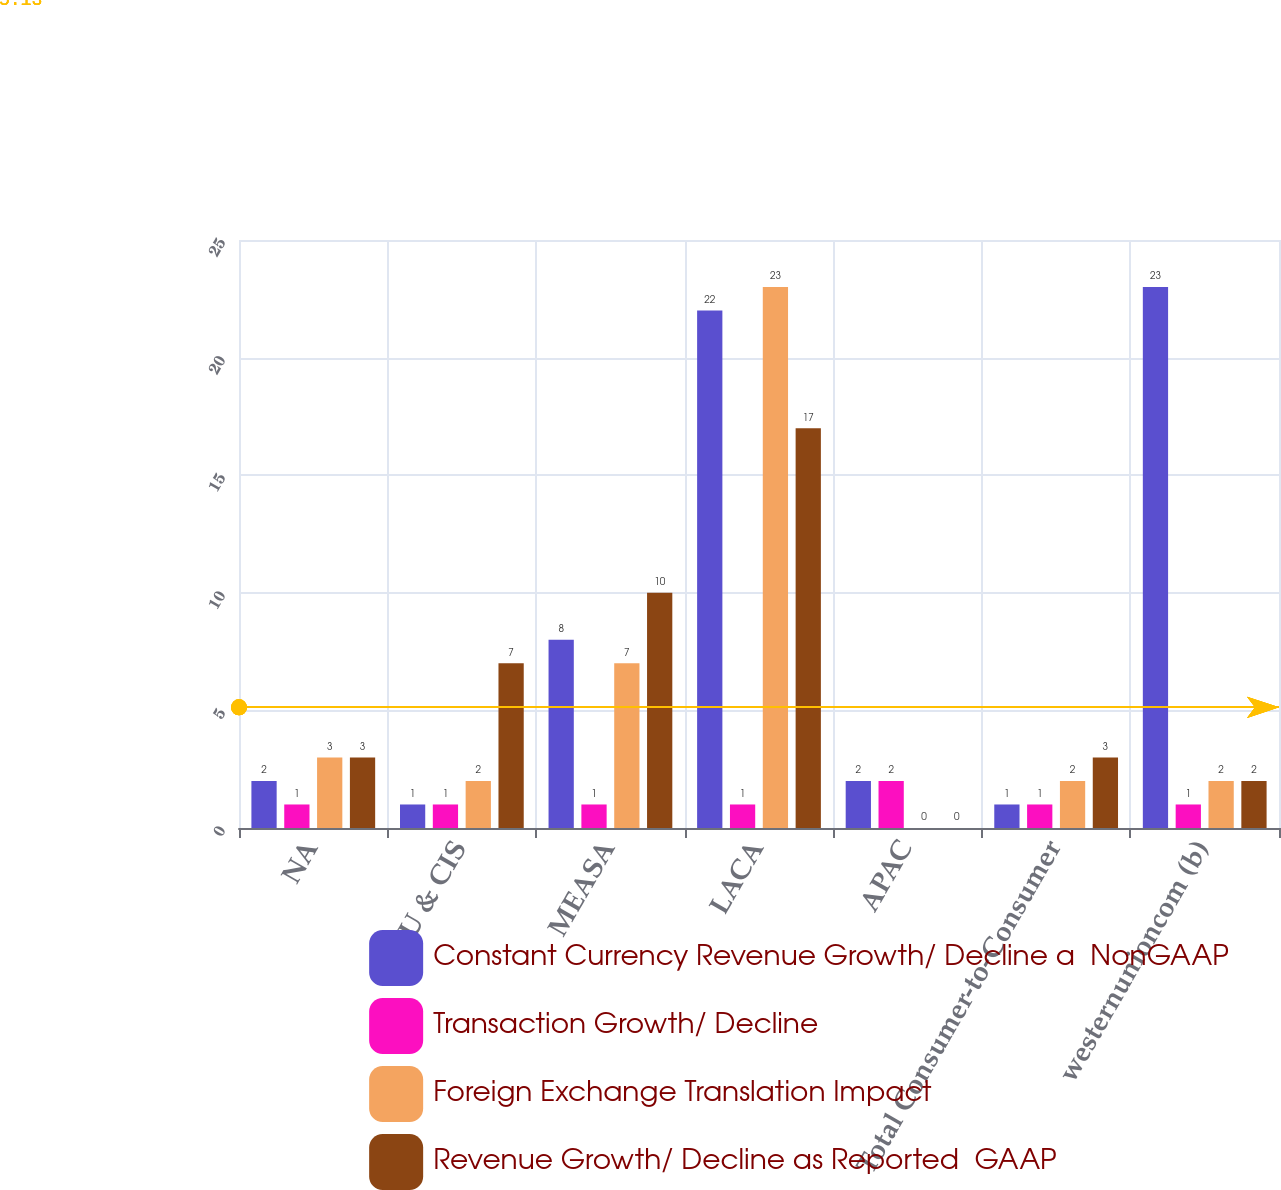<chart> <loc_0><loc_0><loc_500><loc_500><stacked_bar_chart><ecel><fcel>NA<fcel>EU & CIS<fcel>MEASA<fcel>LACA<fcel>APAC<fcel>Total Consumer-to-Consumer<fcel>westernunioncom (b)<nl><fcel>Constant Currency Revenue Growth/ Decline a  NonGAAP<fcel>2<fcel>1<fcel>8<fcel>22<fcel>2<fcel>1<fcel>23<nl><fcel>Transaction Growth/ Decline<fcel>1<fcel>1<fcel>1<fcel>1<fcel>2<fcel>1<fcel>1<nl><fcel>Foreign Exchange Translation Impact<fcel>3<fcel>2<fcel>7<fcel>23<fcel>0<fcel>2<fcel>2<nl><fcel>Revenue Growth/ Decline as Reported  GAAP<fcel>3<fcel>7<fcel>10<fcel>17<fcel>0<fcel>3<fcel>2<nl></chart> 